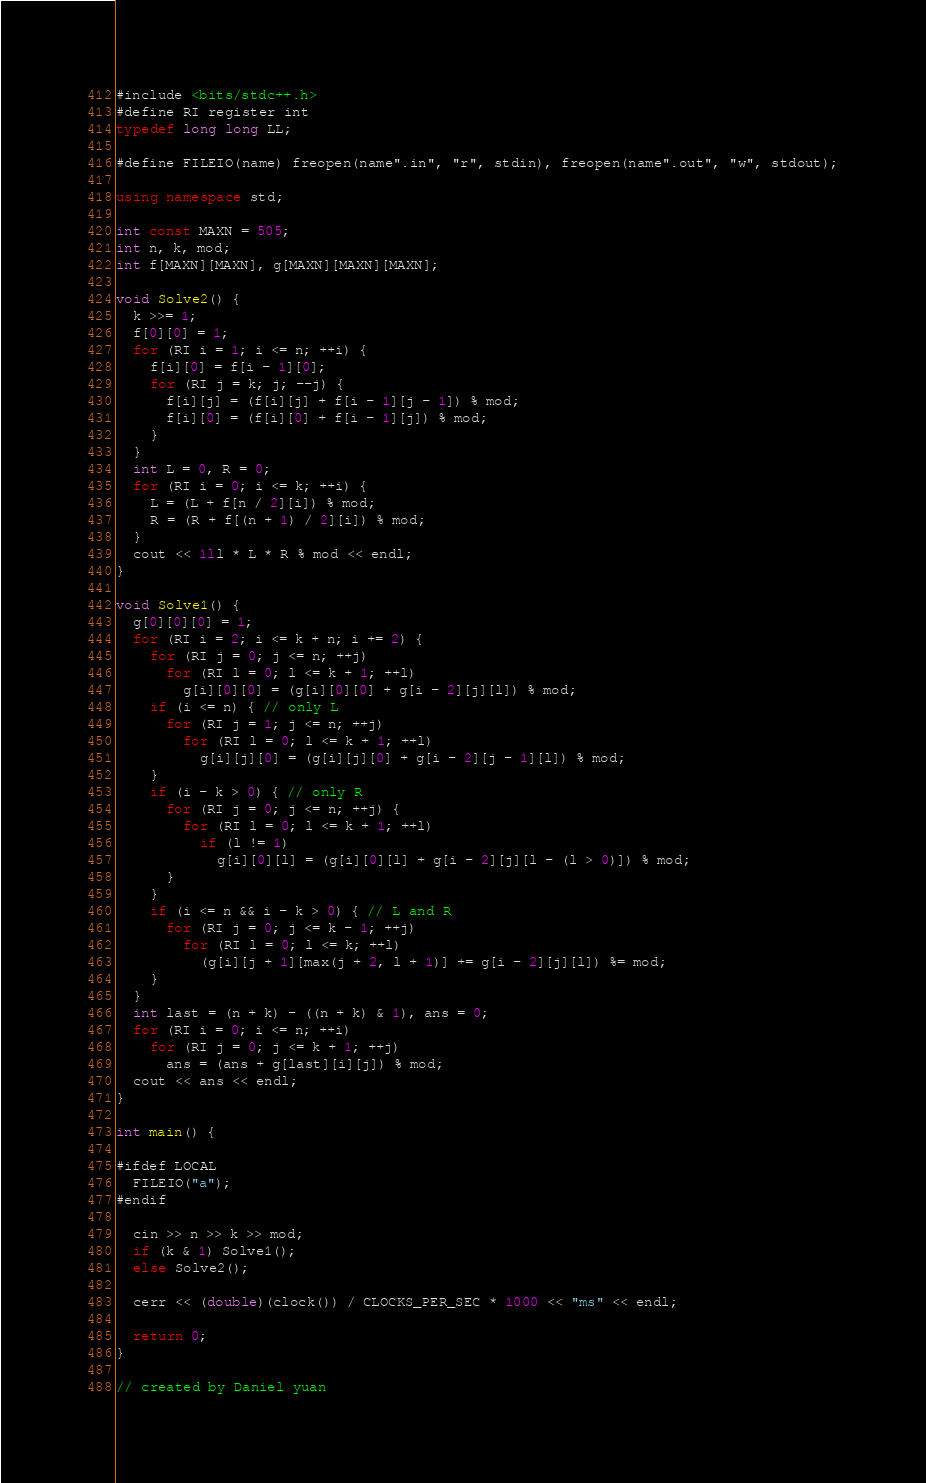Convert code to text. <code><loc_0><loc_0><loc_500><loc_500><_C++_>#include <bits/stdc++.h>
#define RI register int
typedef long long LL;

#define FILEIO(name) freopen(name".in", "r", stdin), freopen(name".out", "w", stdout);

using namespace std;

int const MAXN = 505;
int n, k, mod;
int f[MAXN][MAXN], g[MAXN][MAXN][MAXN];

void Solve2() {
  k >>= 1;
  f[0][0] = 1;
  for (RI i = 1; i <= n; ++i) {
    f[i][0] = f[i - 1][0];
    for (RI j = k; j; --j) {
      f[i][j] = (f[i][j] + f[i - 1][j - 1]) % mod;
      f[i][0] = (f[i][0] + f[i - 1][j]) % mod;
    }
  }
  int L = 0, R = 0;
  for (RI i = 0; i <= k; ++i) {
    L = (L + f[n / 2][i]) % mod;
    R = (R + f[(n + 1) / 2][i]) % mod;
  }
  cout << 1ll * L * R % mod << endl;
}

void Solve1() {
  g[0][0][0] = 1;
  for (RI i = 2; i <= k + n; i += 2) {
    for (RI j = 0; j <= n; ++j)
      for (RI l = 0; l <= k + 1; ++l)
        g[i][0][0] = (g[i][0][0] + g[i - 2][j][l]) % mod;
    if (i <= n) { // only L
      for (RI j = 1; j <= n; ++j)
        for (RI l = 0; l <= k + 1; ++l)
          g[i][j][0] = (g[i][j][0] + g[i - 2][j - 1][l]) % mod;
    }
    if (i - k > 0) { // only R
      for (RI j = 0; j <= n; ++j) {
        for (RI l = 0; l <= k + 1; ++l)
          if (l != 1)
            g[i][0][l] = (g[i][0][l] + g[i - 2][j][l - (l > 0)]) % mod;
      }
    }
    if (i <= n && i - k > 0) { // L and R
      for (RI j = 0; j <= k - 1; ++j)
        for (RI l = 0; l <= k; ++l)
          (g[i][j + 1][max(j + 2, l + 1)] += g[i - 2][j][l]) %= mod;
    }
  }
  int last = (n + k) - ((n + k) & 1), ans = 0;
  for (RI i = 0; i <= n; ++i)
    for (RI j = 0; j <= k + 1; ++j)
      ans = (ans + g[last][i][j]) % mod;
  cout << ans << endl;
}

int main() {

#ifdef LOCAL
  FILEIO("a");
#endif

  cin >> n >> k >> mod;
  if (k & 1) Solve1();
  else Solve2();

  cerr << (double)(clock()) / CLOCKS_PER_SEC * 1000 << "ms" << endl;

  return 0;
}

// created by Daniel yuan</code> 